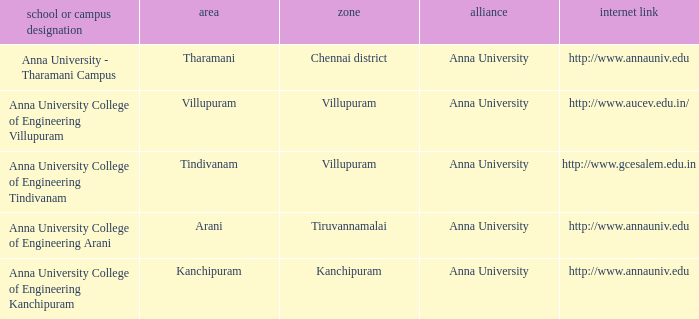What Location has a College or Campus Name of anna university - tharamani campus? Tharamani. 